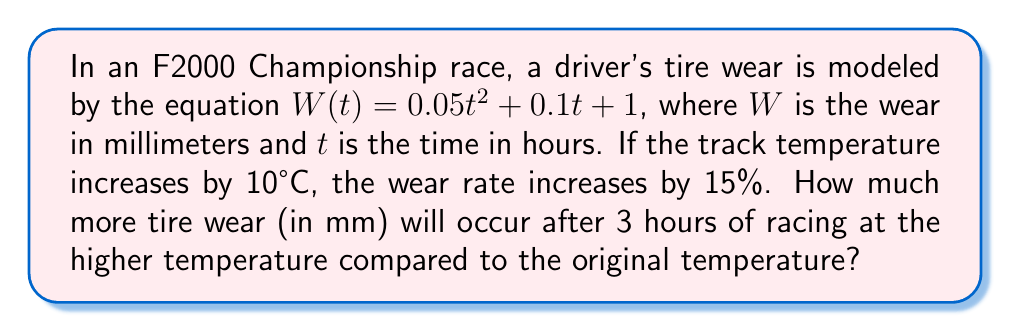Teach me how to tackle this problem. 1. Original wear function: $W(t) = 0.05t^2 + 0.1t + 1$

2. At higher temperature, wear rate increases by 15%:
   New wear function: $W_{new}(t) = 0.05t^2 \cdot 1.15 + 0.1t \cdot 1.15 + 1$
   Simplify: $W_{new}(t) = 0.0575t^2 + 0.115t + 1$

3. Calculate wear at 3 hours for original temperature:
   $W(3) = 0.05(3)^2 + 0.1(3) + 1 = 0.45 + 0.3 + 1 = 1.75$ mm

4. Calculate wear at 3 hours for higher temperature:
   $W_{new}(3) = 0.0575(3)^2 + 0.115(3) + 1 = 0.5175 + 0.345 + 1 = 1.8625$ mm

5. Calculate the difference in wear:
   $\Delta W = W_{new}(3) - W(3) = 1.8625 - 1.75 = 0.1125$ mm
Answer: 0.1125 mm 